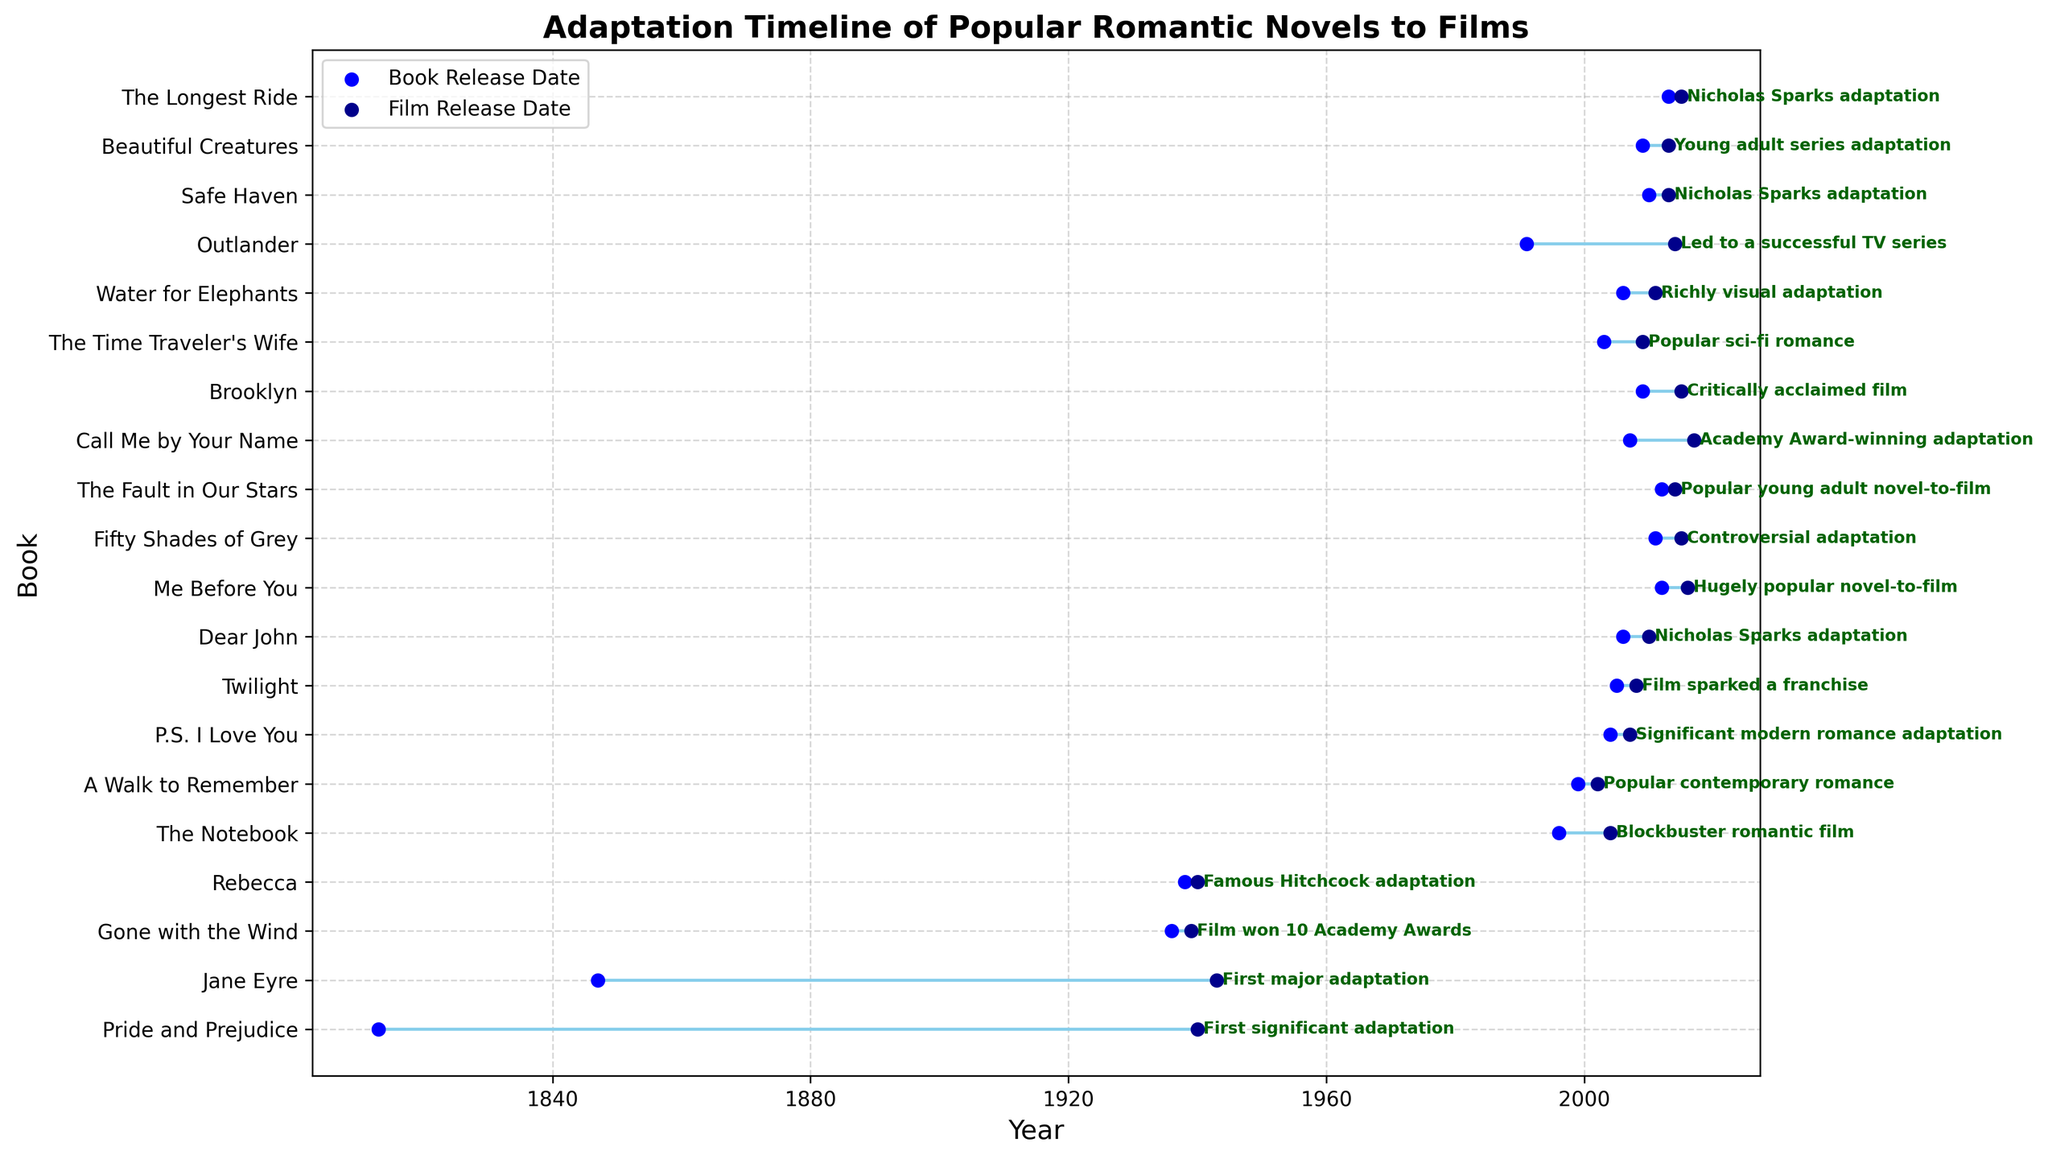What is the length of time between the release of "Pride and Prejudice" and its first major adaptation? To find the length of time between the book release and its film adaptation, subtract the book release year from the film release year for "Pride and Prejudice." The book was released in 1813, and the film adaptation came out in 1940. Therefore, 1940 - 1813 = 127 years.
Answer: 127 years Which adaptation had the shortest time between book release and film release? Compare the lengths of time between the book releases and the film releases for each entry. "Gone with the Wind," released in 1936, had its film adaptation in 1939, making the gap 3 years, which is the shortest among the listed adaptations.
Answer: Gone with the Wind Which adaptation was released before "The Notebook" but after "A Walk to Remember"? To find the adaptation released between these two films, identify the film release dates: "A Walk to Remember" (2002) and "The Notebook" (2004). Search for a film released between these dates. "P.S. I Love You" was released in 2007, which is after both. However, there is no film fitting these exact criteria in the data.
Answer: None How many years did it take for "Outlander" to be adapted into a successful TV series? Subtract the book release year (1991) from the TV series release year (2014). Therefore, 2014 - 1991 = 23 years.
Answer: 23 years Which book adaptation was labeled as a "Famous Hitchcock adaptation"? Identify the book with this milestone. "Rebecca" is noted as the "Famous Hitchcock adaptation," released as a book in 1938 and as a film in 1940.
Answer: Rebecca How many adaptations took over 50 years to be made into films? Count the adaptations where the difference between the book release date and the film release date is over 50 years. "Pride and Prejudice" (127 years), "Jane Eyre" (96 years), and "Outlander" (23 years), "Rebecca" (2 years), and "Gone with the Wind" (3 years) qualify. Three adaptations meet this criterion.
Answer: 3 adaptations Which book adaptation spurred a major film franchise and had its film released in 2008? Identify the book based on the provided details. "Twilight," released as a book in 2005, sparked a franchise with its film adaptation released in 2008.
Answer: Twilight What's the average number of years between book release and film adaptation for Nicholas Sparks novels in the list? First, identify the Nicholas Sparks novels: "The Notebook" (8 years), "A Walk to Remember" (3 years), "Dear John" (4 years), "Safe Haven" (3 years), "The Longest Ride" (2 years). Sum these values (8 + 3 + 4 + 3 + 2 = 20). There are 5 adaptations, so the average is 20/5 = 4 years.
Answer: 4 years Which adaptation resulted in a highly visual film released in 2011? Identify the adaptation based on the milestone. "Water for Elephants," released as a book in 2006, is noted for its richly visual adaptation released in 2011.
Answer: Water for Elephants 